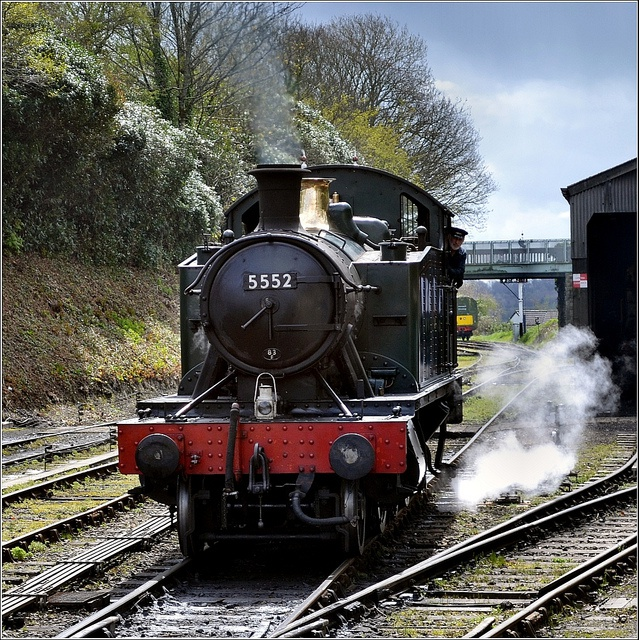Describe the objects in this image and their specific colors. I can see train in black, gray, maroon, and brown tones and people in black and gray tones in this image. 